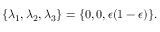<formula> <loc_0><loc_0><loc_500><loc_500>\{ \lambda _ { 1 } , \lambda _ { 2 } , \lambda _ { 3 } \} = \{ 0 , 0 , \epsilon ( 1 - \epsilon ) \} .</formula> 